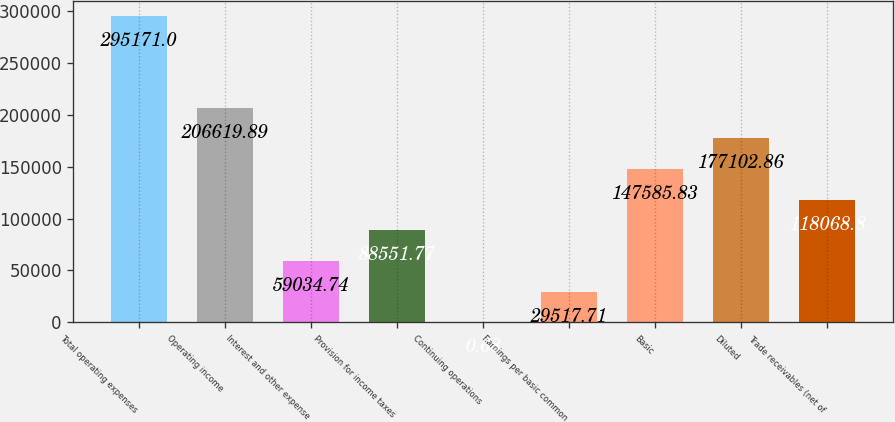Convert chart. <chart><loc_0><loc_0><loc_500><loc_500><bar_chart><fcel>Total operating expenses<fcel>Operating income<fcel>Interest and other expense<fcel>Provision for income taxes<fcel>Continuing operations<fcel>Earnings per basic common<fcel>Basic<fcel>Diluted<fcel>Trade receivables (net of<nl><fcel>295171<fcel>206620<fcel>59034.7<fcel>88551.8<fcel>0.68<fcel>29517.7<fcel>147586<fcel>177103<fcel>118069<nl></chart> 